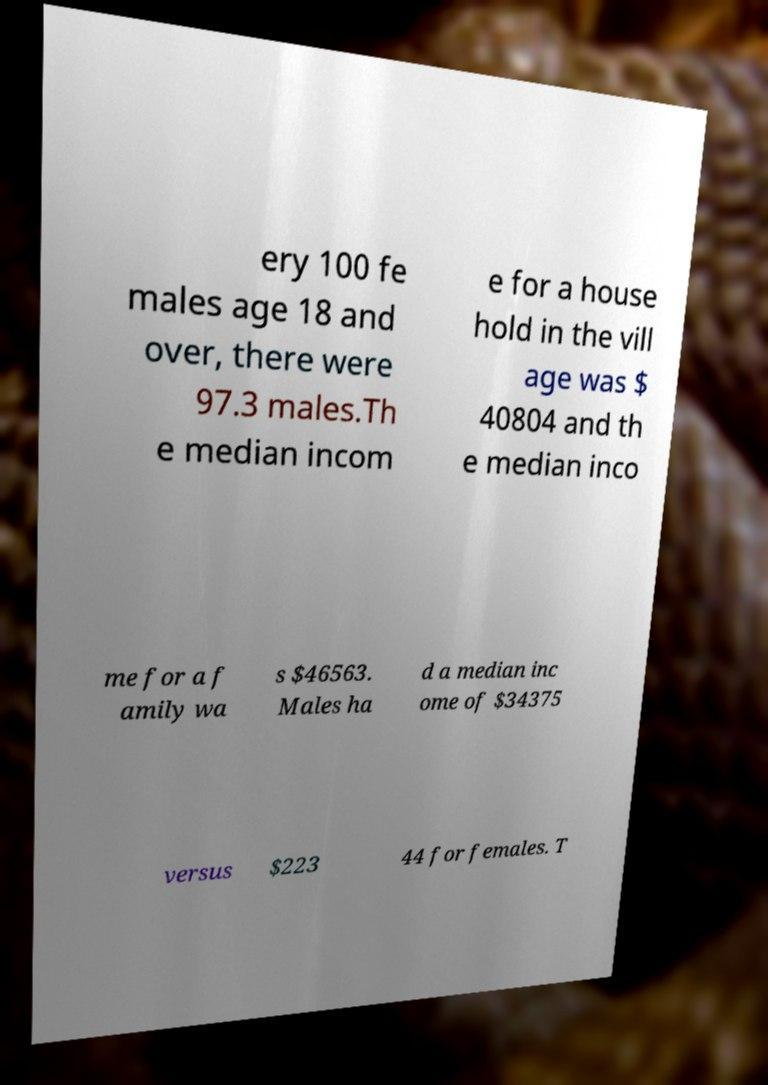For documentation purposes, I need the text within this image transcribed. Could you provide that? ery 100 fe males age 18 and over, there were 97.3 males.Th e median incom e for a house hold in the vill age was $ 40804 and th e median inco me for a f amily wa s $46563. Males ha d a median inc ome of $34375 versus $223 44 for females. T 